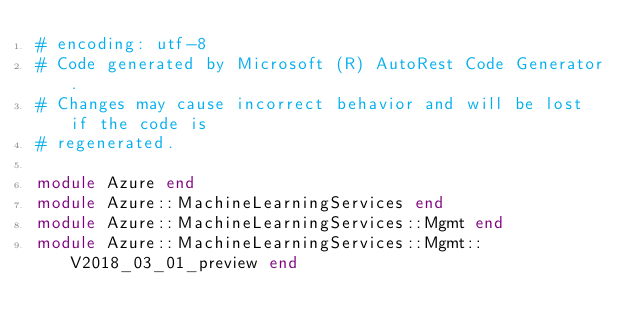<code> <loc_0><loc_0><loc_500><loc_500><_Ruby_># encoding: utf-8
# Code generated by Microsoft (R) AutoRest Code Generator.
# Changes may cause incorrect behavior and will be lost if the code is
# regenerated.

module Azure end
module Azure::MachineLearningServices end
module Azure::MachineLearningServices::Mgmt end
module Azure::MachineLearningServices::Mgmt::V2018_03_01_preview end
</code> 